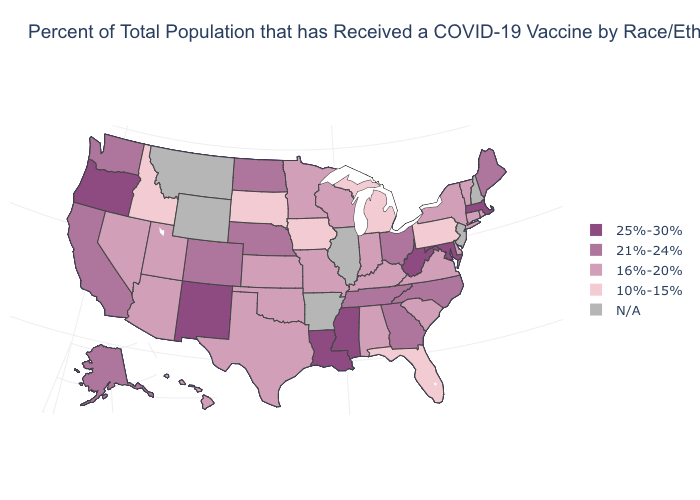What is the lowest value in the MidWest?
Write a very short answer. 10%-15%. What is the value of Arkansas?
Keep it brief. N/A. Name the states that have a value in the range 25%-30%?
Be succinct. Louisiana, Maryland, Massachusetts, Mississippi, New Mexico, Oregon, West Virginia. What is the value of New Hampshire?
Keep it brief. N/A. Name the states that have a value in the range 10%-15%?
Concise answer only. Florida, Idaho, Iowa, Michigan, Pennsylvania, South Dakota. What is the value of Louisiana?
Answer briefly. 25%-30%. Which states have the highest value in the USA?
Be succinct. Louisiana, Maryland, Massachusetts, Mississippi, New Mexico, Oregon, West Virginia. Does the map have missing data?
Answer briefly. Yes. What is the lowest value in the USA?
Answer briefly. 10%-15%. What is the value of Missouri?
Quick response, please. 16%-20%. Does Kentucky have the lowest value in the USA?
Concise answer only. No. What is the value of Ohio?
Answer briefly. 21%-24%. 